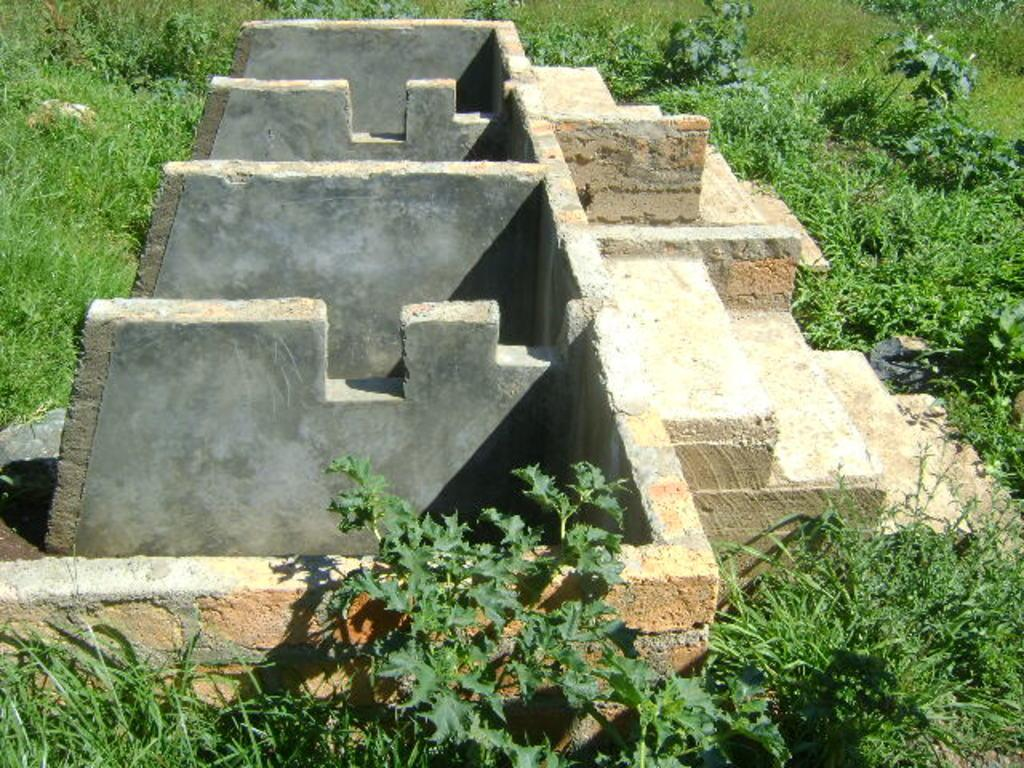What is the main subject of the image? The image depicts a construction. What type of structure is being built in the image? The provided facts do not specify the type of structure being built. What can be seen on the sides of the construction? There is a brick wall on the sides of the construction. Are there any architectural features associated with the construction? Yes, there are steps associated with the construction. What is the natural environment like around the construction? Grasses and plants are present around the construction. Can you tell me how many brothers are standing near the mailbox in the image? There is no mailbox or brother present in the image; it depicts a construction with a brick wall, steps, and surrounding grasses and plants. 